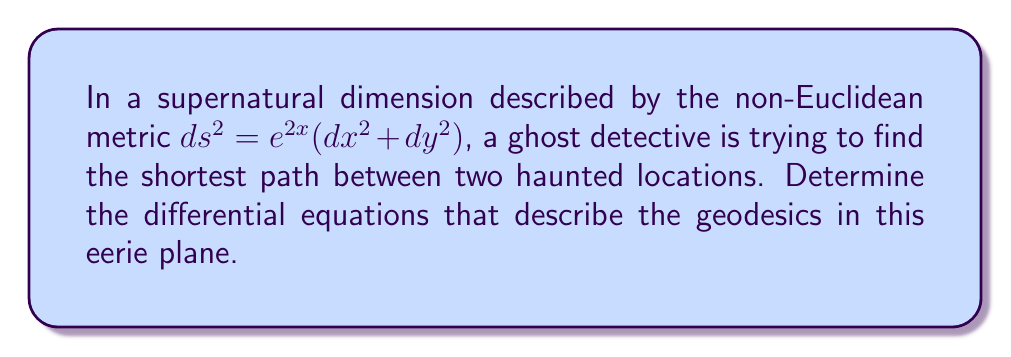Solve this math problem. To find the geodesics in this supernatural dimension, we need to use the Euler-Lagrange equations from the calculus of variations. Let's proceed step-by-step:

1) The metric is given by $ds^2 = e^{2x}(dx^2 + dy^2)$. This means the Lagrangian is:

   $L = \sqrt{e^{2x}(\dot{x}^2 + \dot{y}^2)}$

2) The Euler-Lagrange equations are:

   $$\frac{d}{dt}\left(\frac{\partial L}{\partial \dot{x}}\right) = \frac{\partial L}{\partial x}$$
   $$\frac{d}{dt}\left(\frac{\partial L}{\partial \dot{y}}\right) = \frac{\partial L}{\partial y}$$

3) Let's calculate the partial derivatives:

   $\frac{\partial L}{\partial \dot{x}} = \frac{e^{2x}\dot{x}}{\sqrt{e^{2x}(\dot{x}^2 + \dot{y}^2)}}$

   $\frac{\partial L}{\partial \dot{y}} = \frac{e^{2x}\dot{y}}{\sqrt{e^{2x}(\dot{x}^2 + \dot{y}^2)}}$

   $\frac{\partial L}{\partial x} = \frac{e^{2x}(\dot{x}^2 + \dot{y}^2)}{\sqrt{e^{2x}(\dot{x}^2 + \dot{y}^2)}}$

   $\frac{\partial L}{\partial y} = 0$

4) Now, let's apply the Euler-Lagrange equations:

   For x:
   $$\frac{d}{dt}\left(\frac{e^{2x}\dot{x}}{\sqrt{e^{2x}(\dot{x}^2 + \dot{y}^2)}}\right) = e^{2x}\sqrt{e^{2x}(\dot{x}^2 + \dot{y}^2)}$$

   For y:
   $$\frac{d}{dt}\left(\frac{e^{2x}\dot{y}}{\sqrt{e^{2x}(\dot{x}^2 + \dot{y}^2)}}\right) = 0$$

5) Simplify the y equation:

   $\frac{e^{2x}\dot{y}}{\sqrt{e^{2x}(\dot{x}^2 + \dot{y}^2)}} = C$ (constant)

6) Simplify the x equation:

   After some algebraic manipulation, we get:

   $$\ddot{x} + \dot{x}^2 - \dot{y}^2 = 0$$

These two equations describe the geodesics in this supernatural dimension.
Answer: $$\frac{e^{2x}\dot{y}}{\sqrt{e^{2x}(\dot{x}^2 + \dot{y}^2)}} = C, \quad \ddot{x} + \dot{x}^2 - \dot{y}^2 = 0$$ 